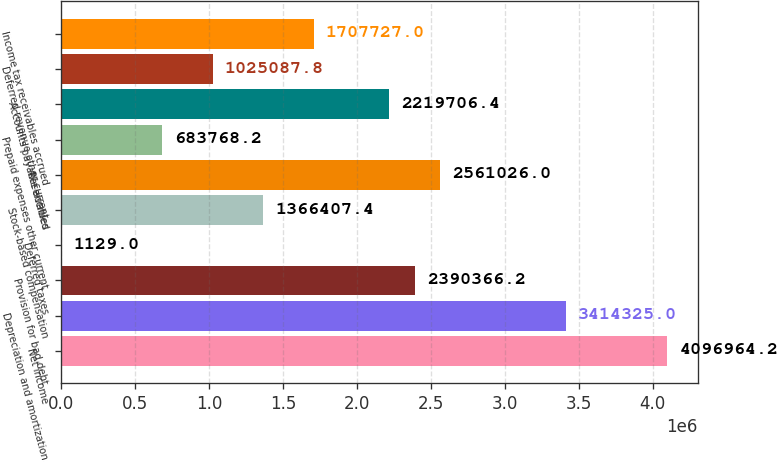Convert chart to OTSL. <chart><loc_0><loc_0><loc_500><loc_500><bar_chart><fcel>Net income<fcel>Depreciation and amortization<fcel>Provision for bad debt<fcel>Deferred taxes<fcel>Stock-based compensation<fcel>Receivables<fcel>Prepaid expenses other current<fcel>Accounts payable accrued<fcel>Deferred revenue other current<fcel>Income tax receivables accrued<nl><fcel>4.09696e+06<fcel>3.41432e+06<fcel>2.39037e+06<fcel>1129<fcel>1.36641e+06<fcel>2.56103e+06<fcel>683768<fcel>2.21971e+06<fcel>1.02509e+06<fcel>1.70773e+06<nl></chart> 